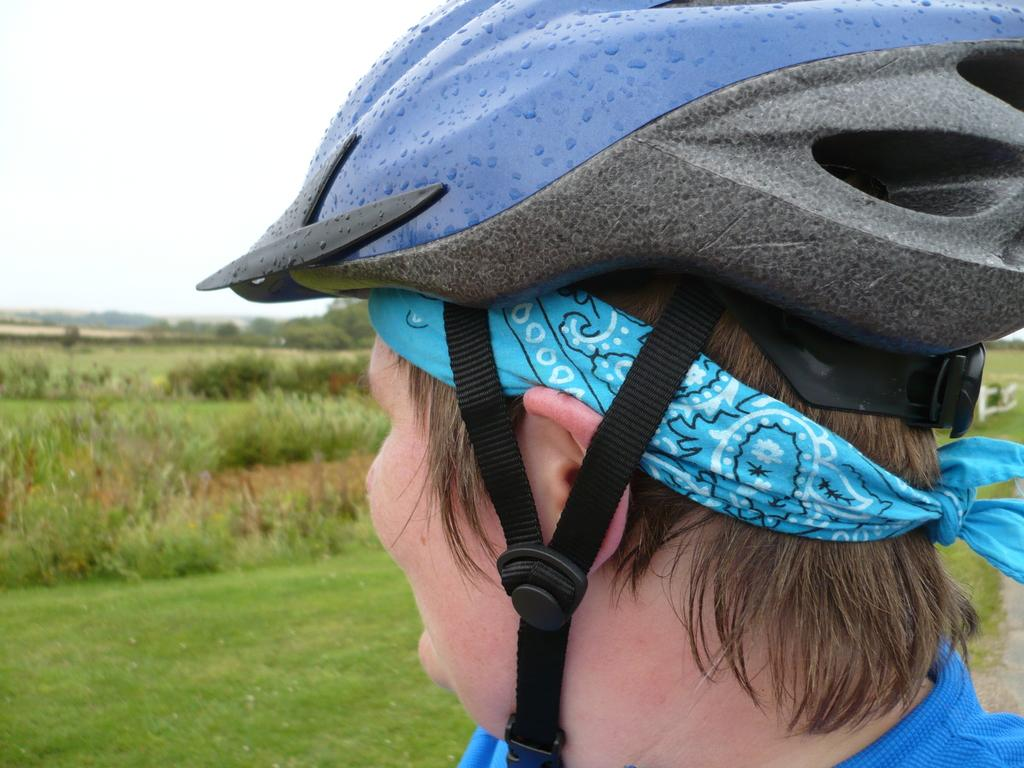What is the main subject of the image? There is a person in the image. What is the person wearing on their head? The person is wearing a helmet. What additional headwear is the person using? The person is tying a kerchief around their head. What type of natural environment can be seen in the background of the image? There are shrubs, bushes, trees, and the sky visible in the background of the image. What type of ground is visible in the background of the image? There is ground visible in the background of the image. What type of music is the band playing in the background of the image? There is no band present in the image, so it is not possible to determine what type of music being played. 